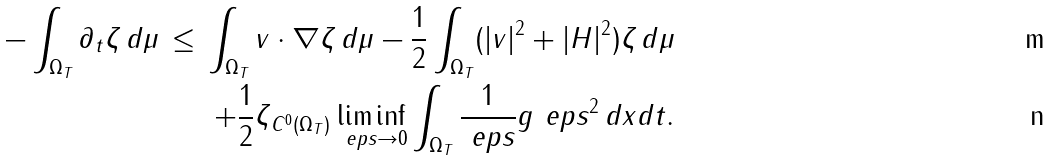Convert formula to latex. <formula><loc_0><loc_0><loc_500><loc_500>- \int _ { \Omega _ { T } } \partial _ { t } \zeta \, d \mu \, \leq \, \int _ { \Omega _ { T } } v \cdot \nabla \zeta \, d \mu - \frac { 1 } { 2 } \int _ { \Omega _ { T } } ( | v | ^ { 2 } + | H | ^ { 2 } ) \zeta \, d \mu \\ + \frac { 1 } { 2 } \| \zeta \| _ { C ^ { 0 } ( \Omega _ { T } ) } \liminf _ { \ e p s \to 0 } \int _ { \Omega _ { T } } \frac { 1 } { \ e p s } g _ { \ } e p s ^ { 2 } \, d x d t .</formula> 